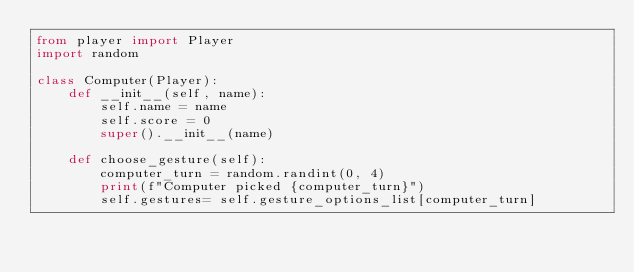<code> <loc_0><loc_0><loc_500><loc_500><_Python_>from player import Player
import random

class Computer(Player):
    def __init__(self, name):
        self.name = name
        self.score = 0
        super().__init__(name)

    def choose_gesture(self):
        computer_turn = random.randint(0, 4)
        print(f"Computer picked {computer_turn}")
        self.gestures= self.gesture_options_list[computer_turn]
</code> 